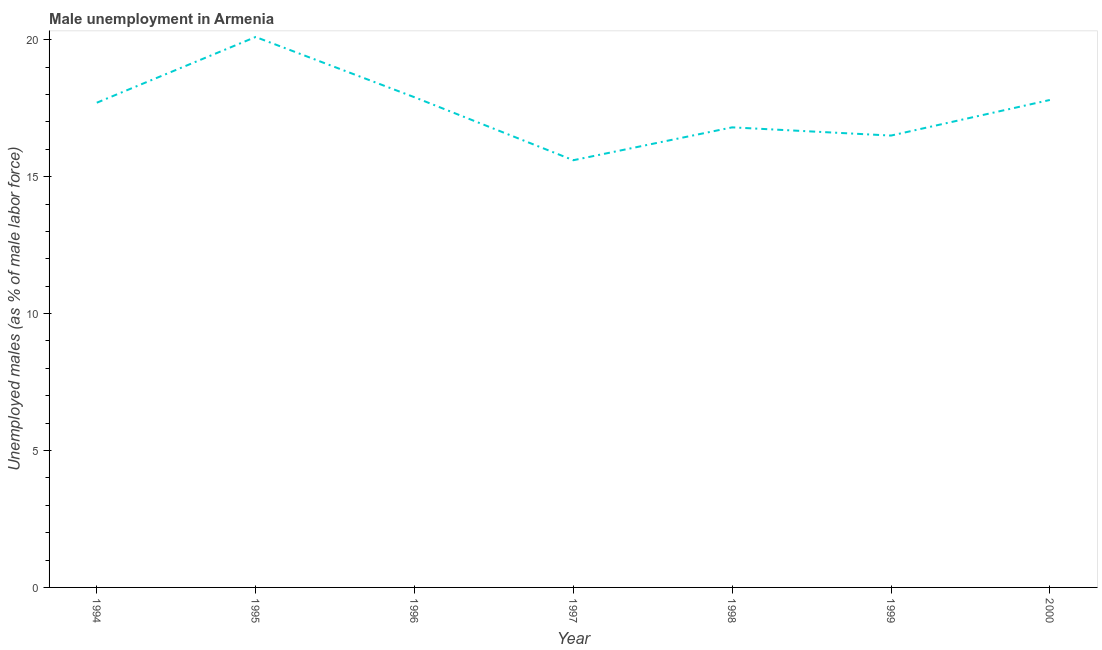What is the unemployed males population in 1998?
Your answer should be very brief. 16.8. Across all years, what is the maximum unemployed males population?
Make the answer very short. 20.1. Across all years, what is the minimum unemployed males population?
Offer a terse response. 15.6. What is the sum of the unemployed males population?
Provide a succinct answer. 122.4. What is the difference between the unemployed males population in 1994 and 1999?
Offer a very short reply. 1.2. What is the average unemployed males population per year?
Your answer should be compact. 17.49. What is the median unemployed males population?
Offer a terse response. 17.7. What is the ratio of the unemployed males population in 1994 to that in 2000?
Your answer should be compact. 0.99. Is the unemployed males population in 1996 less than that in 1997?
Provide a short and direct response. No. What is the difference between the highest and the second highest unemployed males population?
Ensure brevity in your answer.  2.2. Is the sum of the unemployed males population in 1996 and 1998 greater than the maximum unemployed males population across all years?
Keep it short and to the point. Yes. What is the difference between the highest and the lowest unemployed males population?
Provide a succinct answer. 4.5. In how many years, is the unemployed males population greater than the average unemployed males population taken over all years?
Your answer should be compact. 4. Does the unemployed males population monotonically increase over the years?
Keep it short and to the point. No. How many years are there in the graph?
Your answer should be compact. 7. Does the graph contain grids?
Your response must be concise. No. What is the title of the graph?
Your answer should be compact. Male unemployment in Armenia. What is the label or title of the Y-axis?
Ensure brevity in your answer.  Unemployed males (as % of male labor force). What is the Unemployed males (as % of male labor force) of 1994?
Offer a terse response. 17.7. What is the Unemployed males (as % of male labor force) in 1995?
Offer a terse response. 20.1. What is the Unemployed males (as % of male labor force) of 1996?
Offer a very short reply. 17.9. What is the Unemployed males (as % of male labor force) in 1997?
Keep it short and to the point. 15.6. What is the Unemployed males (as % of male labor force) in 1998?
Keep it short and to the point. 16.8. What is the Unemployed males (as % of male labor force) of 2000?
Your response must be concise. 17.8. What is the difference between the Unemployed males (as % of male labor force) in 1994 and 1995?
Give a very brief answer. -2.4. What is the difference between the Unemployed males (as % of male labor force) in 1994 and 1998?
Offer a terse response. 0.9. What is the difference between the Unemployed males (as % of male labor force) in 1995 and 1996?
Offer a terse response. 2.2. What is the difference between the Unemployed males (as % of male labor force) in 1995 and 1999?
Offer a terse response. 3.6. What is the difference between the Unemployed males (as % of male labor force) in 1995 and 2000?
Keep it short and to the point. 2.3. What is the difference between the Unemployed males (as % of male labor force) in 1997 and 1999?
Offer a very short reply. -0.9. What is the difference between the Unemployed males (as % of male labor force) in 1998 and 2000?
Make the answer very short. -1. What is the ratio of the Unemployed males (as % of male labor force) in 1994 to that in 1995?
Ensure brevity in your answer.  0.88. What is the ratio of the Unemployed males (as % of male labor force) in 1994 to that in 1996?
Offer a very short reply. 0.99. What is the ratio of the Unemployed males (as % of male labor force) in 1994 to that in 1997?
Ensure brevity in your answer.  1.14. What is the ratio of the Unemployed males (as % of male labor force) in 1994 to that in 1998?
Make the answer very short. 1.05. What is the ratio of the Unemployed males (as % of male labor force) in 1994 to that in 1999?
Give a very brief answer. 1.07. What is the ratio of the Unemployed males (as % of male labor force) in 1994 to that in 2000?
Your answer should be very brief. 0.99. What is the ratio of the Unemployed males (as % of male labor force) in 1995 to that in 1996?
Provide a short and direct response. 1.12. What is the ratio of the Unemployed males (as % of male labor force) in 1995 to that in 1997?
Your answer should be compact. 1.29. What is the ratio of the Unemployed males (as % of male labor force) in 1995 to that in 1998?
Provide a short and direct response. 1.2. What is the ratio of the Unemployed males (as % of male labor force) in 1995 to that in 1999?
Your response must be concise. 1.22. What is the ratio of the Unemployed males (as % of male labor force) in 1995 to that in 2000?
Keep it short and to the point. 1.13. What is the ratio of the Unemployed males (as % of male labor force) in 1996 to that in 1997?
Provide a succinct answer. 1.15. What is the ratio of the Unemployed males (as % of male labor force) in 1996 to that in 1998?
Your answer should be very brief. 1.06. What is the ratio of the Unemployed males (as % of male labor force) in 1996 to that in 1999?
Ensure brevity in your answer.  1.08. What is the ratio of the Unemployed males (as % of male labor force) in 1997 to that in 1998?
Offer a very short reply. 0.93. What is the ratio of the Unemployed males (as % of male labor force) in 1997 to that in 1999?
Ensure brevity in your answer.  0.94. What is the ratio of the Unemployed males (as % of male labor force) in 1997 to that in 2000?
Provide a succinct answer. 0.88. What is the ratio of the Unemployed males (as % of male labor force) in 1998 to that in 2000?
Your response must be concise. 0.94. What is the ratio of the Unemployed males (as % of male labor force) in 1999 to that in 2000?
Provide a short and direct response. 0.93. 